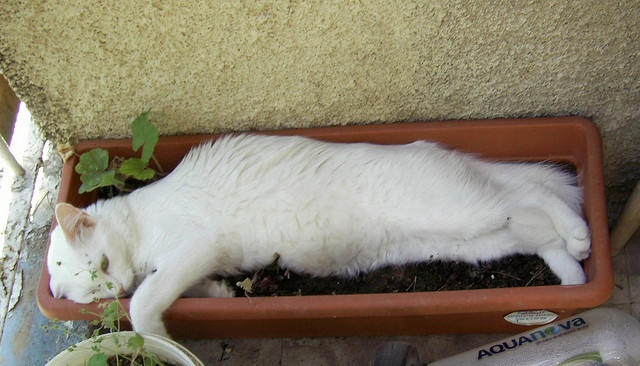Describe the objects in this image and their specific colors. I can see cat in gray, lightgray, darkgray, and black tones, potted plant in gray, darkgray, and darkgreen tones, and potted plant in gray, darkgreen, black, maroon, and olive tones in this image. 